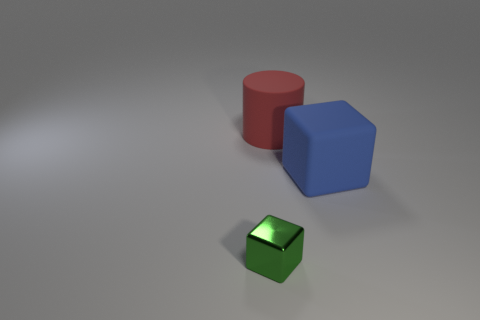Add 1 big blue things. How many objects exist? 4 Subtract all cylinders. How many objects are left? 2 Subtract all green cubes. How many cubes are left? 1 Subtract 1 cylinders. How many cylinders are left? 0 Subtract all cyan cubes. Subtract all red cylinders. How many cubes are left? 2 Subtract all yellow cylinders. How many brown blocks are left? 0 Subtract all green shiny things. Subtract all small cyan matte cylinders. How many objects are left? 2 Add 2 big blue blocks. How many big blue blocks are left? 3 Add 2 green cubes. How many green cubes exist? 3 Subtract 1 red cylinders. How many objects are left? 2 